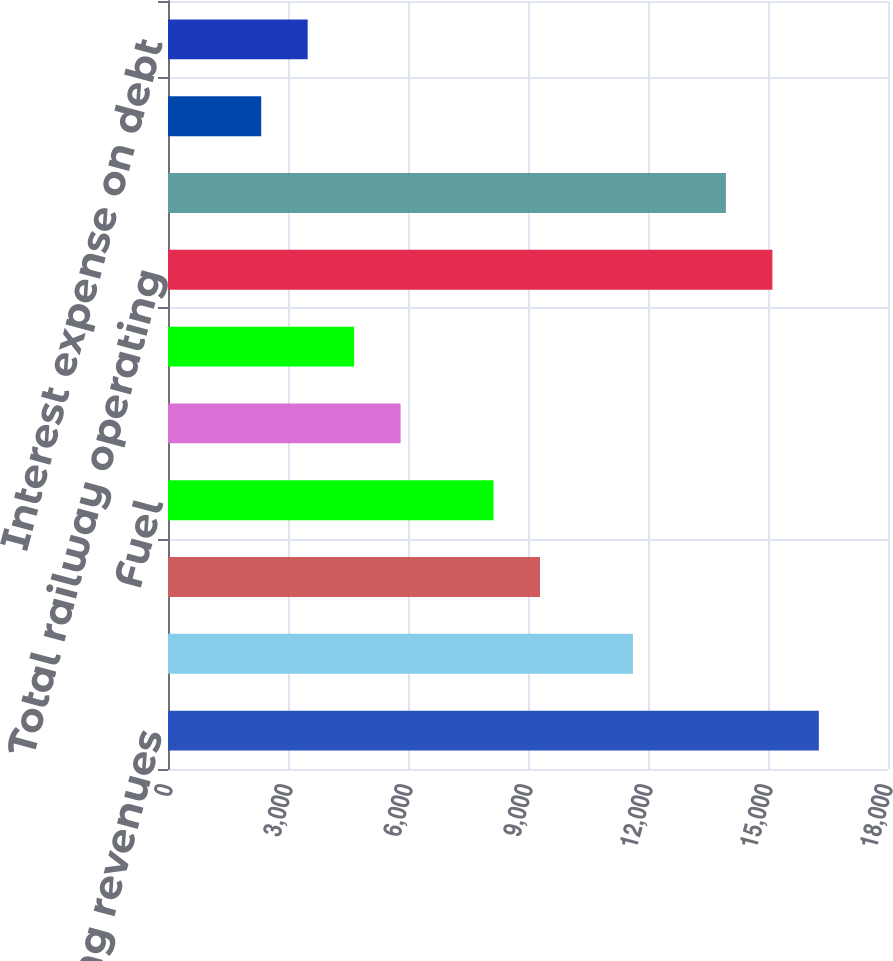Convert chart to OTSL. <chart><loc_0><loc_0><loc_500><loc_500><bar_chart><fcel>Railway operating revenues<fcel>Compensation and benefits<fcel>Purchased services and rents<fcel>Fuel<fcel>Depreciation<fcel>Materials and other<fcel>Total railway operating<fcel>Income from railway operations<fcel>Other income - net<fcel>Interest expense on debt<nl><fcel>16271<fcel>11624<fcel>9300.47<fcel>8138.71<fcel>5815.19<fcel>4653.43<fcel>15109.3<fcel>13947.5<fcel>2329.91<fcel>3491.67<nl></chart> 